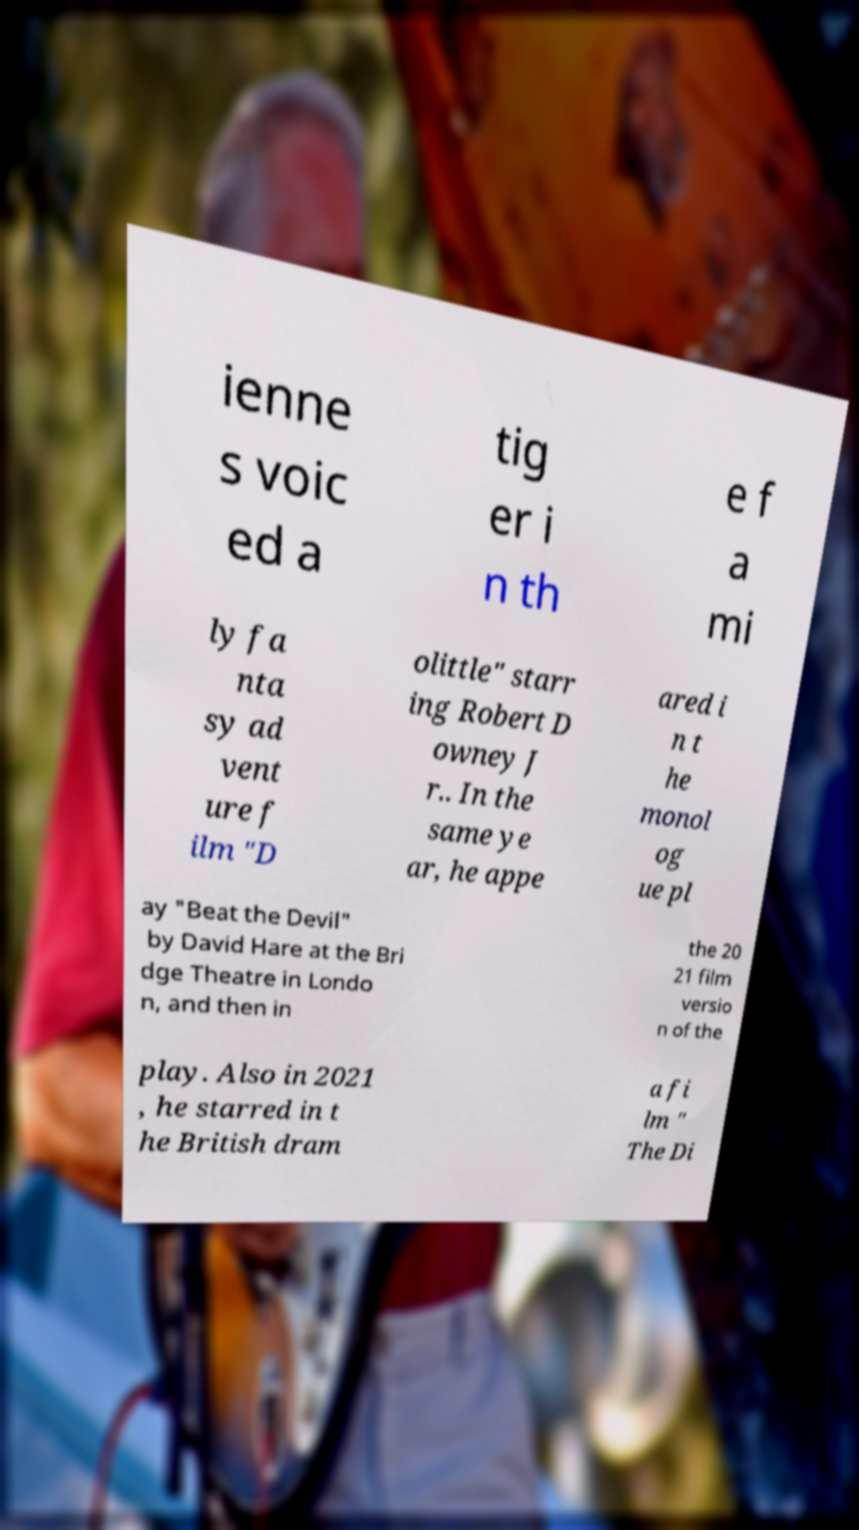What messages or text are displayed in this image? I need them in a readable, typed format. ienne s voic ed a tig er i n th e f a mi ly fa nta sy ad vent ure f ilm "D olittle" starr ing Robert D owney J r.. In the same ye ar, he appe ared i n t he monol og ue pl ay "Beat the Devil" by David Hare at the Bri dge Theatre in Londo n, and then in the 20 21 film versio n of the play. Also in 2021 , he starred in t he British dram a fi lm " The Di 